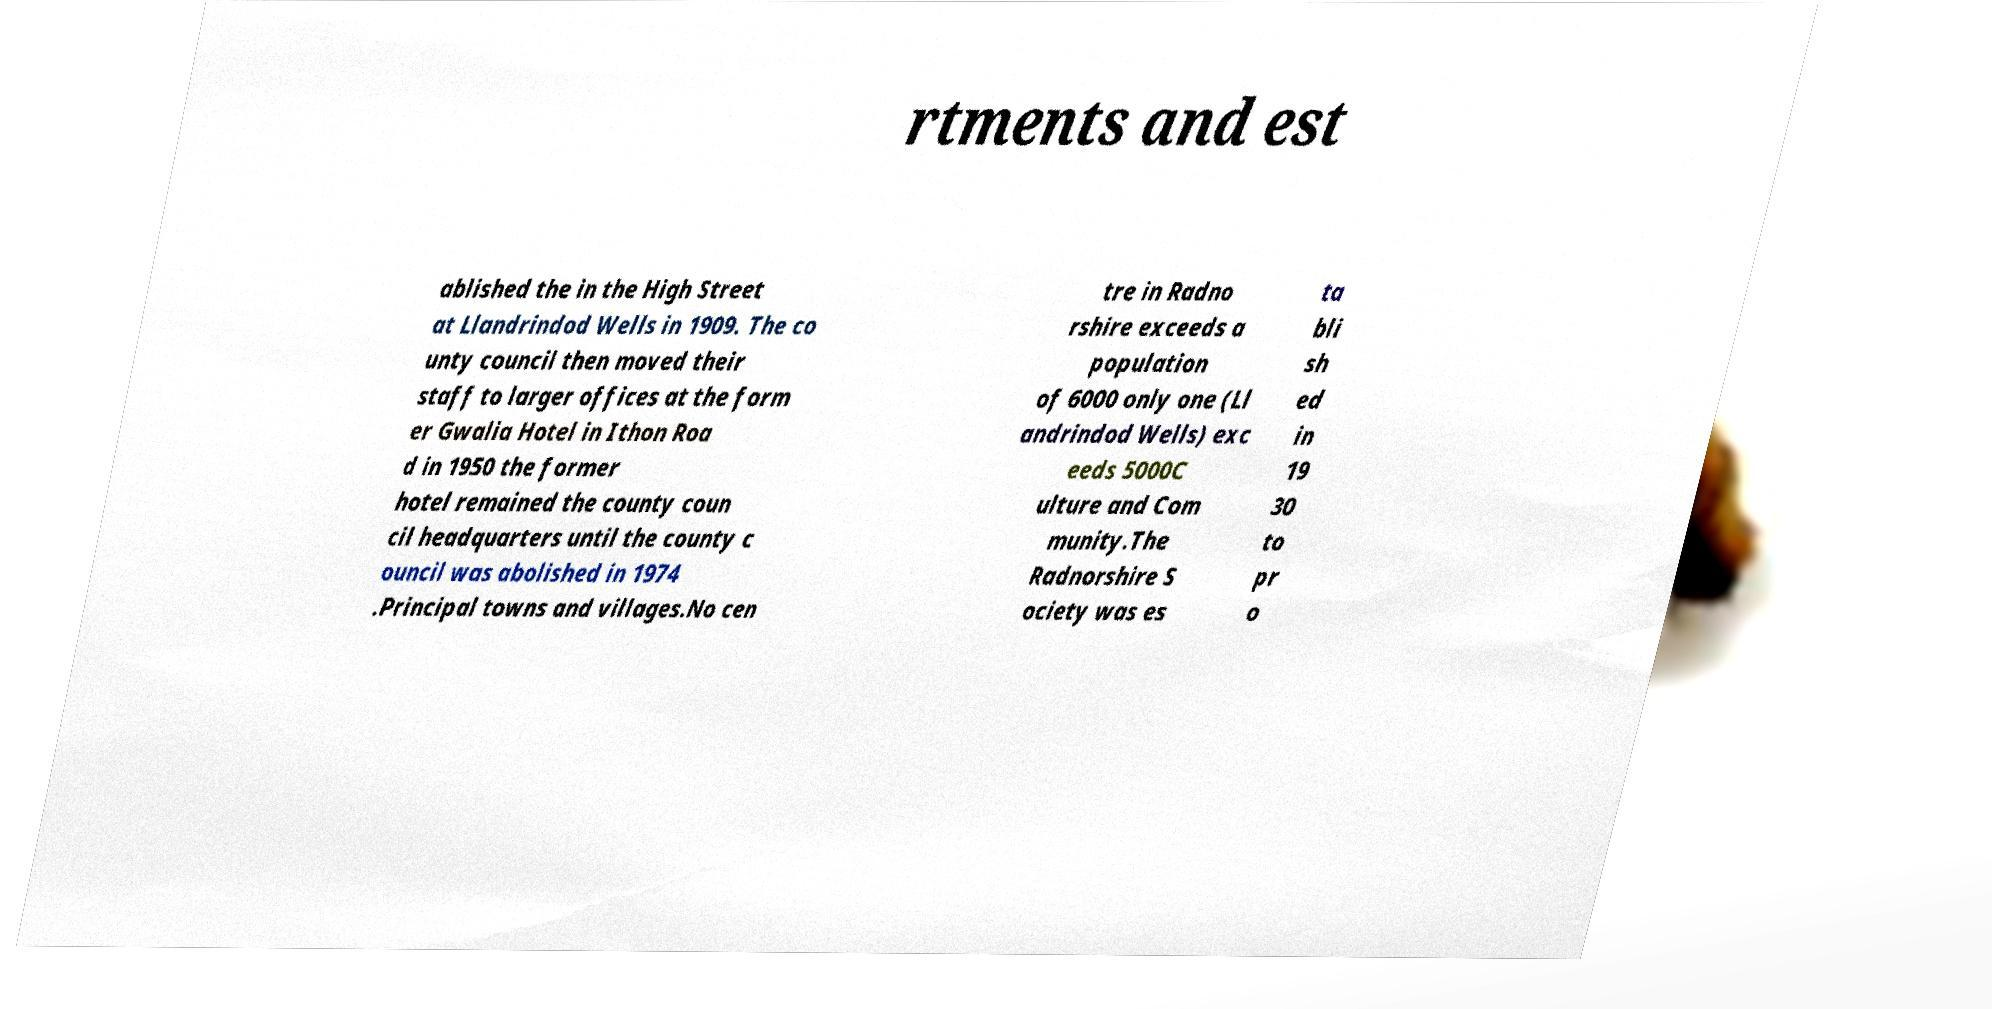I need the written content from this picture converted into text. Can you do that? rtments and est ablished the in the High Street at Llandrindod Wells in 1909. The co unty council then moved their staff to larger offices at the form er Gwalia Hotel in Ithon Roa d in 1950 the former hotel remained the county coun cil headquarters until the county c ouncil was abolished in 1974 .Principal towns and villages.No cen tre in Radno rshire exceeds a population of 6000 only one (Ll andrindod Wells) exc eeds 5000C ulture and Com munity.The Radnorshire S ociety was es ta bli sh ed in 19 30 to pr o 